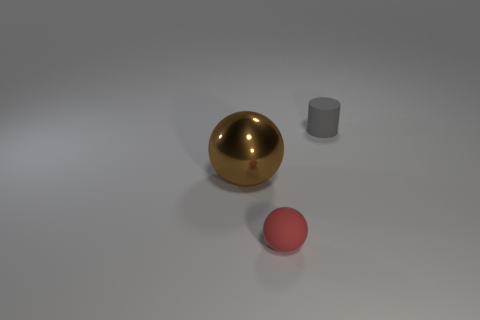What shape is the thing that is both left of the rubber cylinder and behind the tiny red ball?
Your response must be concise. Sphere. There is a object on the left side of the tiny thing to the left of the tiny gray cylinder behind the brown metal object; what is its shape?
Your response must be concise. Sphere. There is a thing that is both behind the small red object and in front of the small gray rubber cylinder; what material is it?
Provide a succinct answer. Metal. What number of other metallic objects are the same size as the brown object?
Keep it short and to the point. 0. What number of shiny things are tiny balls or tiny brown cubes?
Offer a very short reply. 0. What material is the gray cylinder?
Your answer should be compact. Rubber. How many red things are to the right of the gray object?
Offer a terse response. 0. Are the small object behind the metal object and the tiny sphere made of the same material?
Provide a succinct answer. Yes. How many other matte objects have the same shape as the brown thing?
Provide a short and direct response. 1. How many big objects are either cylinders or yellow objects?
Keep it short and to the point. 0. 